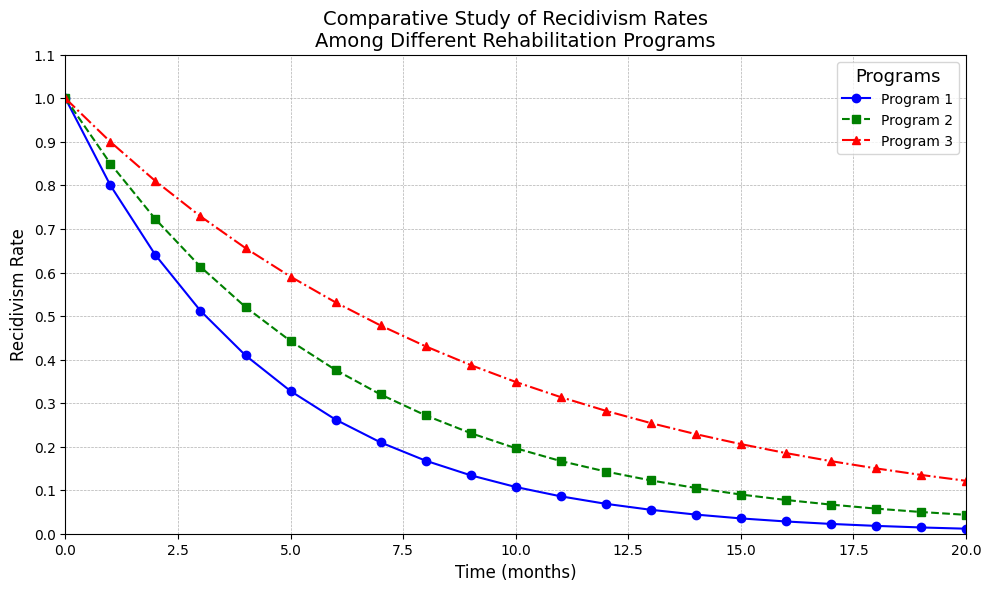what is the recidivism rate for program 1 at time = 10 months? At time = 10 months, locate the data point on the blue line corresponding to program 1 and check the y-axis value
Answer: 0.107 Which program shows the lowest recidivism rate at time = 5 months? Compare the values at time = 5 months for all three programs. Program 1: ~0.328, Program 2: ~0.443, Program 3: ~0.590
Answer: Program 1 What is the difference in recidivism rates between program 2 and program 3 at time = 4 months? At time = 4 months, find the recidivism rates for program 2 (~0.521) and program 3 (~0.656). Calculate the difference (~0.656 - ~0.521)
Answer: ~0.135 Which program shows the slowest rate of decay in recidivism over the period observed? Observing the slope of the decay in the recidivism rates; The green line (Program 2) declines slower compared to the blue and red lines.
Answer: Program 2 At which time point do programs 2 and 3 have approximately the same recidivism rate? Find the intersection point of the green line (Program 2) and the red line (Program 3). They intersect around time = 8 months where both are around ~0.27
Answer: ~8 months At time = 15 months, how much higher is the recidivism rate for program 3 compared to program 1? Find the values at 15 months for program 3 (~0.206) and program 1 (0.035). Calculate the difference (~0.206 - 0.035)
Answer: ~0.171 What visual attribute distinguishes program 1 in the plot? Program 1 is represented by a blue solid line with circle markers
Answer: Blue solid line with circles How does the recidivism rate of program 1 at time = 20 months compare to that of program 2 at the same time? At 20 months, compare the rates of program 1 (~0.012) and program 2 (~0.043). Program 2 has a higher rate
Answer: Program 2 is higher Which program has the steepest decline in the initial 3 months? Observe the trend from time = 0 to 3 months and compare the slopes; Program 1 (blue line) has the steepest decline
Answer: Program 1 How many programs have a recidivism rate below 0.1 by time = 20 months? At time = 20 months, check the y-values of all programs. Program 1 and Program 2 are below 0.1.
Answer: 2 